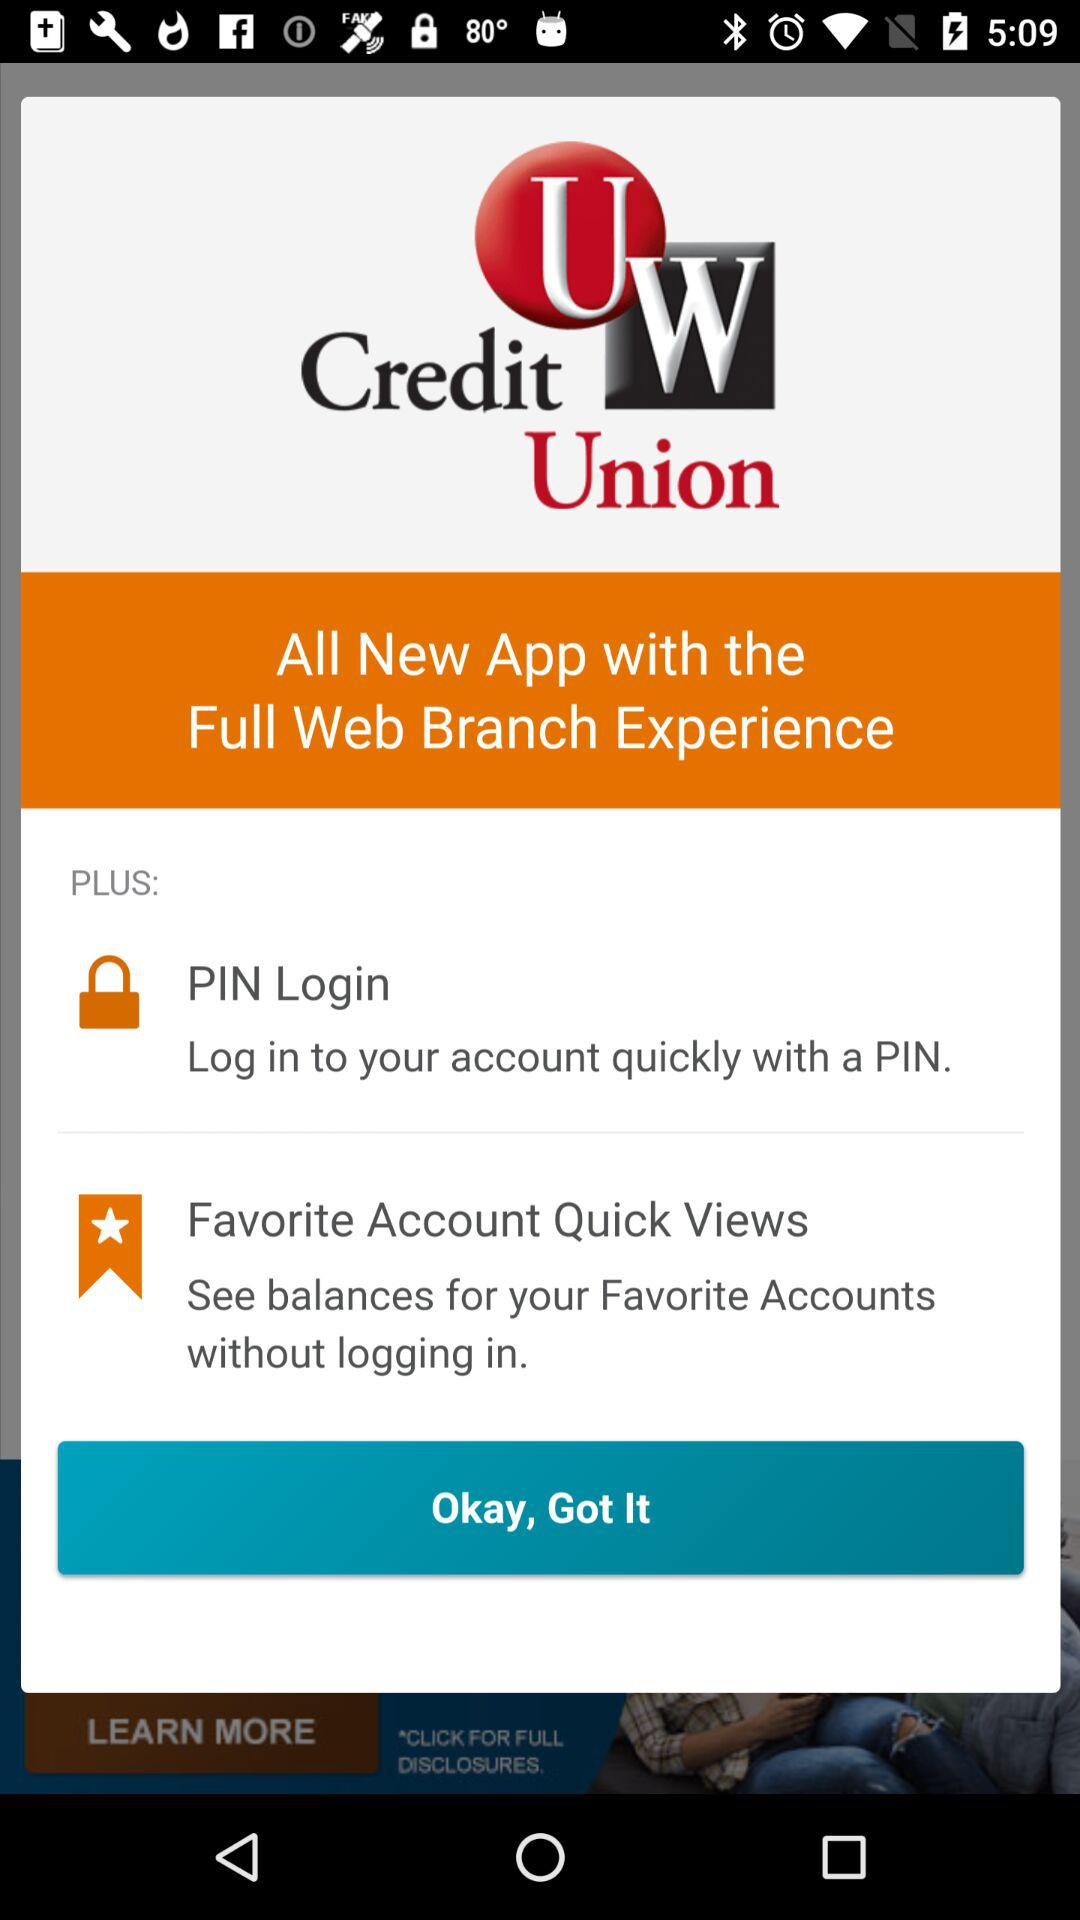What is the name of the application? The name of the application is "UW Credit Union". 